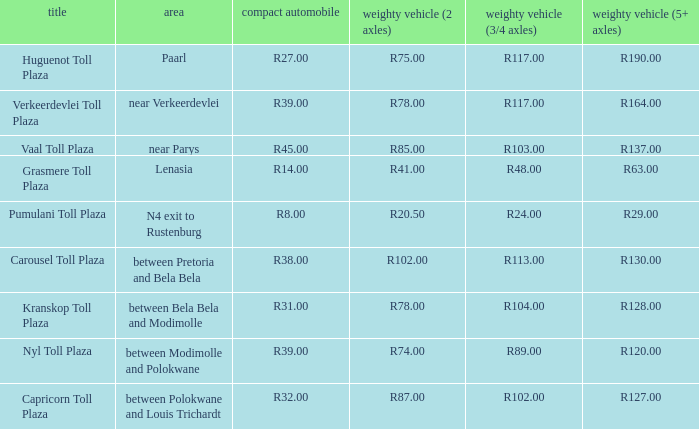What is the toll for heavy vehicles with 3/4 axles at Verkeerdevlei toll plaza? R117.00. 